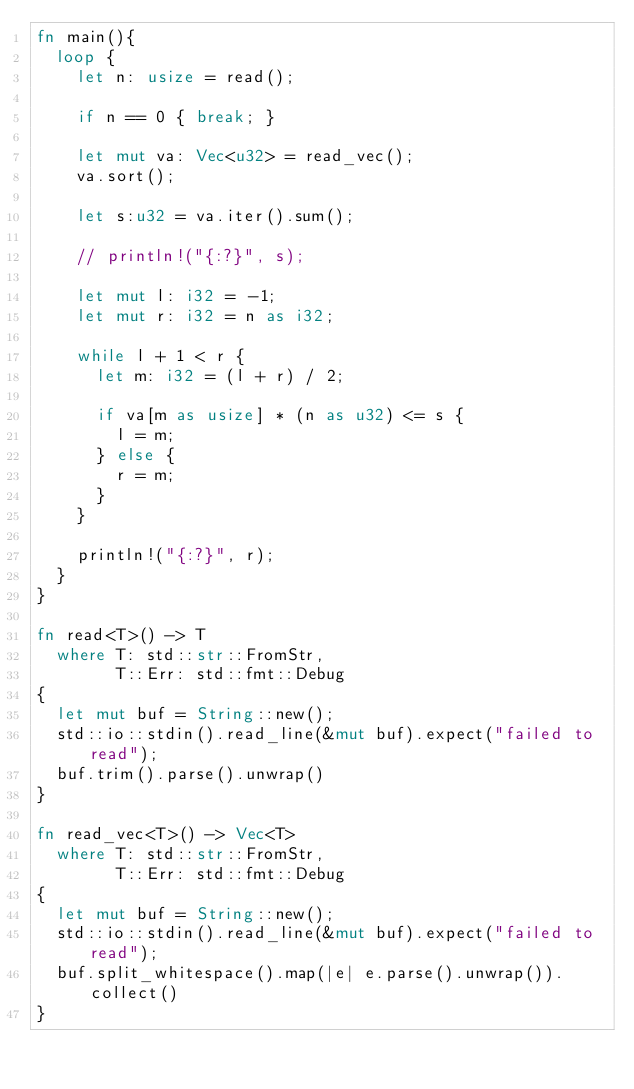Convert code to text. <code><loc_0><loc_0><loc_500><loc_500><_Rust_>fn main(){
  loop {
    let n: usize = read();

    if n == 0 { break; }
    
    let mut va: Vec<u32> = read_vec();
    va.sort();
    
    let s:u32 = va.iter().sum();
    
    // println!("{:?}", s);

    let mut l: i32 = -1;
    let mut r: i32 = n as i32;

    while l + 1 < r {
      let m: i32 = (l + r) / 2;

      if va[m as usize] * (n as u32) <= s {
        l = m;
      } else {
        r = m;
      }
    }

    println!("{:?}", r);
  }
}

fn read<T>() -> T
  where T: std::str::FromStr,
        T::Err: std::fmt::Debug
{
  let mut buf = String::new();
  std::io::stdin().read_line(&mut buf).expect("failed to read");
  buf.trim().parse().unwrap()
}

fn read_vec<T>() -> Vec<T>
  where T: std::str::FromStr,
        T::Err: std::fmt::Debug
{
  let mut buf = String::new();
  std::io::stdin().read_line(&mut buf).expect("failed to read");
  buf.split_whitespace().map(|e| e.parse().unwrap()).collect()
}

</code> 